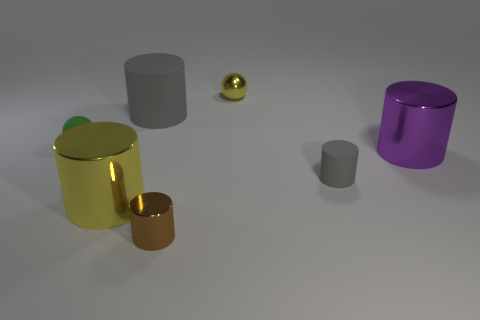How many large gray rubber things are the same shape as the small green matte object?
Your response must be concise. 0. What shape is the tiny yellow metallic thing?
Your answer should be very brief. Sphere. There is a gray matte cylinder that is behind the ball on the left side of the brown cylinder; what size is it?
Ensure brevity in your answer.  Large. How many objects are either small yellow metal balls or tiny things?
Give a very brief answer. 4. Do the green rubber thing and the tiny yellow metallic object have the same shape?
Offer a very short reply. Yes. Are there any tiny green things that have the same material as the purple object?
Your answer should be very brief. No. There is a tiny thing that is left of the brown object; are there any big matte things that are on the right side of it?
Keep it short and to the point. Yes. Is the size of the yellow metal ball behind the purple cylinder the same as the brown metal cylinder?
Make the answer very short. Yes. The yellow metal sphere is what size?
Give a very brief answer. Small. Is there a big block of the same color as the matte sphere?
Offer a very short reply. No. 